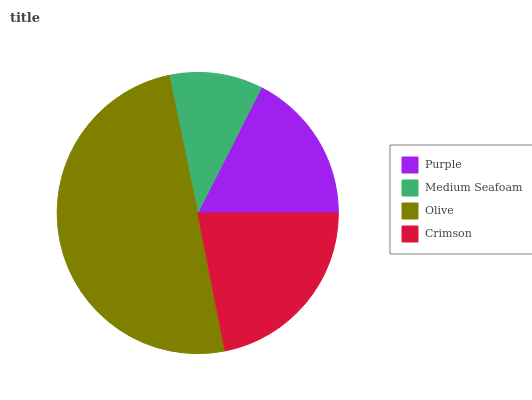Is Medium Seafoam the minimum?
Answer yes or no. Yes. Is Olive the maximum?
Answer yes or no. Yes. Is Olive the minimum?
Answer yes or no. No. Is Medium Seafoam the maximum?
Answer yes or no. No. Is Olive greater than Medium Seafoam?
Answer yes or no. Yes. Is Medium Seafoam less than Olive?
Answer yes or no. Yes. Is Medium Seafoam greater than Olive?
Answer yes or no. No. Is Olive less than Medium Seafoam?
Answer yes or no. No. Is Crimson the high median?
Answer yes or no. Yes. Is Purple the low median?
Answer yes or no. Yes. Is Olive the high median?
Answer yes or no. No. Is Medium Seafoam the low median?
Answer yes or no. No. 